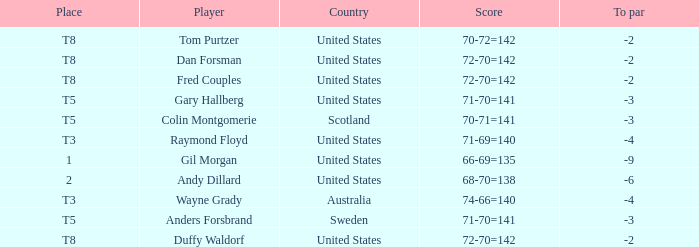What is the T8 Place Player? Fred Couples, Dan Forsman, Tom Purtzer, Duffy Waldorf. 